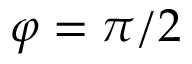<formula> <loc_0><loc_0><loc_500><loc_500>\varphi = \pi / 2</formula> 